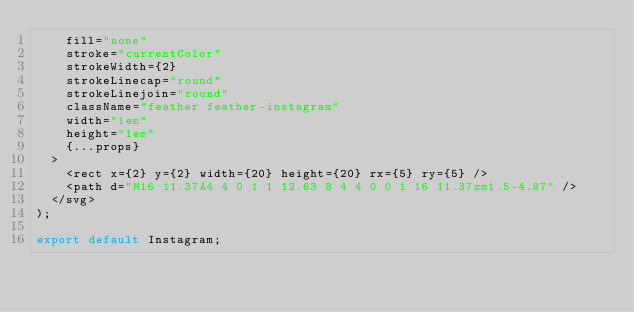<code> <loc_0><loc_0><loc_500><loc_500><_JavaScript_>		fill="none"
		stroke="currentColor"
		strokeWidth={2}
		strokeLinecap="round"
		strokeLinejoin="round"
		className="feather feather-instagram"
		width="1em"
		height="1em"
		{...props}
	>
		<rect x={2} y={2} width={20} height={20} rx={5} ry={5} />
		<path d="M16 11.37A4 4 0 1 1 12.63 8 4 4 0 0 1 16 11.37zm1.5-4.87" />
	</svg>
);

export default Instagram;
</code> 